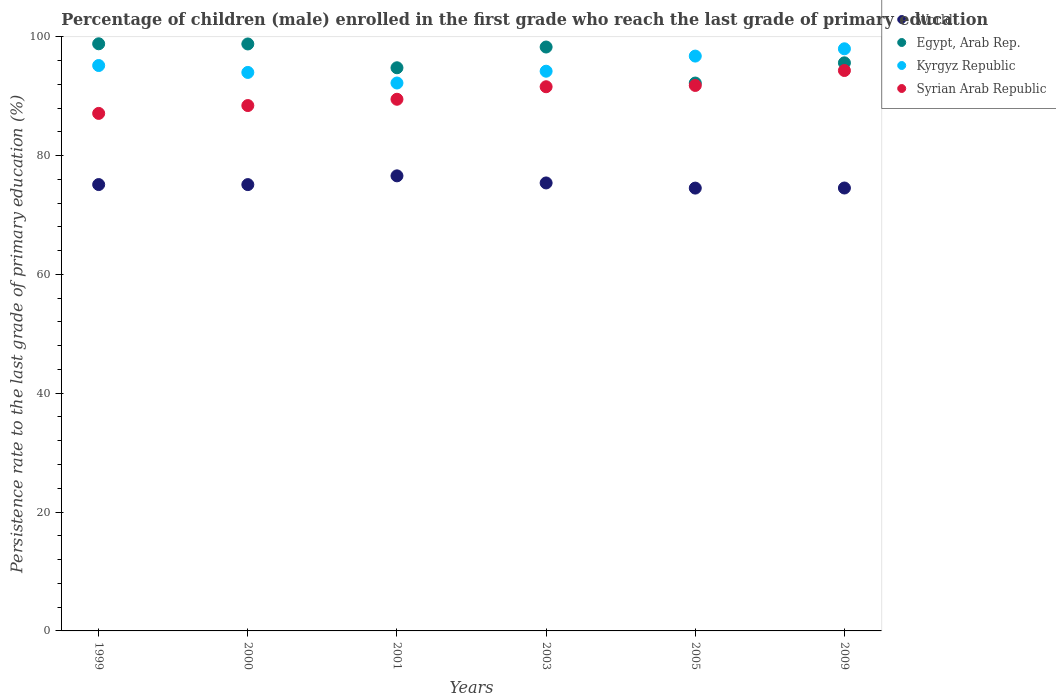How many different coloured dotlines are there?
Ensure brevity in your answer.  4. Is the number of dotlines equal to the number of legend labels?
Keep it short and to the point. Yes. What is the persistence rate of children in Kyrgyz Republic in 2000?
Offer a terse response. 93.99. Across all years, what is the maximum persistence rate of children in Egypt, Arab Rep.?
Offer a very short reply. 98.81. Across all years, what is the minimum persistence rate of children in World?
Offer a terse response. 74.52. In which year was the persistence rate of children in Syrian Arab Republic maximum?
Give a very brief answer. 2009. In which year was the persistence rate of children in Kyrgyz Republic minimum?
Keep it short and to the point. 2001. What is the total persistence rate of children in Syrian Arab Republic in the graph?
Offer a very short reply. 542.65. What is the difference between the persistence rate of children in Egypt, Arab Rep. in 1999 and that in 2009?
Your response must be concise. 3.2. What is the difference between the persistence rate of children in Egypt, Arab Rep. in 2003 and the persistence rate of children in Syrian Arab Republic in 1999?
Give a very brief answer. 11.17. What is the average persistence rate of children in Kyrgyz Republic per year?
Provide a succinct answer. 95.04. In the year 2001, what is the difference between the persistence rate of children in Egypt, Arab Rep. and persistence rate of children in World?
Ensure brevity in your answer.  18.19. What is the ratio of the persistence rate of children in Syrian Arab Republic in 2000 to that in 2003?
Keep it short and to the point. 0.97. Is the persistence rate of children in Egypt, Arab Rep. in 2000 less than that in 2001?
Provide a short and direct response. No. Is the difference between the persistence rate of children in Egypt, Arab Rep. in 2003 and 2009 greater than the difference between the persistence rate of children in World in 2003 and 2009?
Offer a terse response. Yes. What is the difference between the highest and the second highest persistence rate of children in World?
Make the answer very short. 1.19. What is the difference between the highest and the lowest persistence rate of children in Syrian Arab Republic?
Your response must be concise. 7.22. In how many years, is the persistence rate of children in Egypt, Arab Rep. greater than the average persistence rate of children in Egypt, Arab Rep. taken over all years?
Keep it short and to the point. 3. Is the sum of the persistence rate of children in Syrian Arab Republic in 2003 and 2009 greater than the maximum persistence rate of children in World across all years?
Your response must be concise. Yes. Is it the case that in every year, the sum of the persistence rate of children in Egypt, Arab Rep. and persistence rate of children in Kyrgyz Republic  is greater than the sum of persistence rate of children in Syrian Arab Republic and persistence rate of children in World?
Provide a short and direct response. Yes. Is the persistence rate of children in Kyrgyz Republic strictly less than the persistence rate of children in World over the years?
Keep it short and to the point. No. How many dotlines are there?
Make the answer very short. 4. How many years are there in the graph?
Offer a terse response. 6. Does the graph contain grids?
Make the answer very short. No. Where does the legend appear in the graph?
Provide a succinct answer. Top right. How many legend labels are there?
Your response must be concise. 4. How are the legend labels stacked?
Ensure brevity in your answer.  Vertical. What is the title of the graph?
Provide a short and direct response. Percentage of children (male) enrolled in the first grade who reach the last grade of primary education. What is the label or title of the Y-axis?
Offer a very short reply. Persistence rate to the last grade of primary education (%). What is the Persistence rate to the last grade of primary education (%) of World in 1999?
Offer a terse response. 75.12. What is the Persistence rate to the last grade of primary education (%) in Egypt, Arab Rep. in 1999?
Make the answer very short. 98.81. What is the Persistence rate to the last grade of primary education (%) in Kyrgyz Republic in 1999?
Provide a succinct answer. 95.15. What is the Persistence rate to the last grade of primary education (%) in Syrian Arab Republic in 1999?
Make the answer very short. 87.09. What is the Persistence rate to the last grade of primary education (%) in World in 2000?
Your answer should be very brief. 75.11. What is the Persistence rate to the last grade of primary education (%) of Egypt, Arab Rep. in 2000?
Make the answer very short. 98.78. What is the Persistence rate to the last grade of primary education (%) in Kyrgyz Republic in 2000?
Provide a short and direct response. 93.99. What is the Persistence rate to the last grade of primary education (%) in Syrian Arab Republic in 2000?
Provide a succinct answer. 88.41. What is the Persistence rate to the last grade of primary education (%) of World in 2001?
Ensure brevity in your answer.  76.58. What is the Persistence rate to the last grade of primary education (%) in Egypt, Arab Rep. in 2001?
Keep it short and to the point. 94.77. What is the Persistence rate to the last grade of primary education (%) of Kyrgyz Republic in 2001?
Your response must be concise. 92.2. What is the Persistence rate to the last grade of primary education (%) in Syrian Arab Republic in 2001?
Your answer should be compact. 89.47. What is the Persistence rate to the last grade of primary education (%) of World in 2003?
Offer a terse response. 75.39. What is the Persistence rate to the last grade of primary education (%) in Egypt, Arab Rep. in 2003?
Make the answer very short. 98.26. What is the Persistence rate to the last grade of primary education (%) in Kyrgyz Republic in 2003?
Offer a terse response. 94.19. What is the Persistence rate to the last grade of primary education (%) of Syrian Arab Republic in 2003?
Your answer should be very brief. 91.58. What is the Persistence rate to the last grade of primary education (%) of World in 2005?
Give a very brief answer. 74.52. What is the Persistence rate to the last grade of primary education (%) in Egypt, Arab Rep. in 2005?
Your answer should be very brief. 92.2. What is the Persistence rate to the last grade of primary education (%) of Kyrgyz Republic in 2005?
Give a very brief answer. 96.74. What is the Persistence rate to the last grade of primary education (%) in Syrian Arab Republic in 2005?
Give a very brief answer. 91.8. What is the Persistence rate to the last grade of primary education (%) in World in 2009?
Provide a short and direct response. 74.54. What is the Persistence rate to the last grade of primary education (%) of Egypt, Arab Rep. in 2009?
Offer a very short reply. 95.6. What is the Persistence rate to the last grade of primary education (%) of Kyrgyz Republic in 2009?
Offer a very short reply. 97.96. What is the Persistence rate to the last grade of primary education (%) of Syrian Arab Republic in 2009?
Give a very brief answer. 94.31. Across all years, what is the maximum Persistence rate to the last grade of primary education (%) in World?
Offer a very short reply. 76.58. Across all years, what is the maximum Persistence rate to the last grade of primary education (%) in Egypt, Arab Rep.?
Keep it short and to the point. 98.81. Across all years, what is the maximum Persistence rate to the last grade of primary education (%) in Kyrgyz Republic?
Your answer should be very brief. 97.96. Across all years, what is the maximum Persistence rate to the last grade of primary education (%) of Syrian Arab Republic?
Your response must be concise. 94.31. Across all years, what is the minimum Persistence rate to the last grade of primary education (%) of World?
Offer a very short reply. 74.52. Across all years, what is the minimum Persistence rate to the last grade of primary education (%) of Egypt, Arab Rep.?
Make the answer very short. 92.2. Across all years, what is the minimum Persistence rate to the last grade of primary education (%) in Kyrgyz Republic?
Provide a succinct answer. 92.2. Across all years, what is the minimum Persistence rate to the last grade of primary education (%) in Syrian Arab Republic?
Offer a terse response. 87.09. What is the total Persistence rate to the last grade of primary education (%) in World in the graph?
Your answer should be very brief. 451.25. What is the total Persistence rate to the last grade of primary education (%) in Egypt, Arab Rep. in the graph?
Offer a very short reply. 578.42. What is the total Persistence rate to the last grade of primary education (%) in Kyrgyz Republic in the graph?
Ensure brevity in your answer.  570.23. What is the total Persistence rate to the last grade of primary education (%) in Syrian Arab Republic in the graph?
Offer a terse response. 542.65. What is the difference between the Persistence rate to the last grade of primary education (%) of World in 1999 and that in 2000?
Offer a terse response. 0.01. What is the difference between the Persistence rate to the last grade of primary education (%) in Egypt, Arab Rep. in 1999 and that in 2000?
Keep it short and to the point. 0.03. What is the difference between the Persistence rate to the last grade of primary education (%) in Kyrgyz Republic in 1999 and that in 2000?
Provide a succinct answer. 1.16. What is the difference between the Persistence rate to the last grade of primary education (%) of Syrian Arab Republic in 1999 and that in 2000?
Your answer should be compact. -1.32. What is the difference between the Persistence rate to the last grade of primary education (%) of World in 1999 and that in 2001?
Your answer should be very brief. -1.47. What is the difference between the Persistence rate to the last grade of primary education (%) of Egypt, Arab Rep. in 1999 and that in 2001?
Offer a terse response. 4.04. What is the difference between the Persistence rate to the last grade of primary education (%) of Kyrgyz Republic in 1999 and that in 2001?
Offer a terse response. 2.94. What is the difference between the Persistence rate to the last grade of primary education (%) of Syrian Arab Republic in 1999 and that in 2001?
Your answer should be compact. -2.38. What is the difference between the Persistence rate to the last grade of primary education (%) of World in 1999 and that in 2003?
Make the answer very short. -0.27. What is the difference between the Persistence rate to the last grade of primary education (%) in Egypt, Arab Rep. in 1999 and that in 2003?
Give a very brief answer. 0.54. What is the difference between the Persistence rate to the last grade of primary education (%) in Syrian Arab Republic in 1999 and that in 2003?
Ensure brevity in your answer.  -4.49. What is the difference between the Persistence rate to the last grade of primary education (%) of World in 1999 and that in 2005?
Provide a succinct answer. 0.59. What is the difference between the Persistence rate to the last grade of primary education (%) in Egypt, Arab Rep. in 1999 and that in 2005?
Keep it short and to the point. 6.61. What is the difference between the Persistence rate to the last grade of primary education (%) of Kyrgyz Republic in 1999 and that in 2005?
Make the answer very short. -1.59. What is the difference between the Persistence rate to the last grade of primary education (%) in Syrian Arab Republic in 1999 and that in 2005?
Offer a terse response. -4.7. What is the difference between the Persistence rate to the last grade of primary education (%) in World in 1999 and that in 2009?
Provide a short and direct response. 0.58. What is the difference between the Persistence rate to the last grade of primary education (%) of Egypt, Arab Rep. in 1999 and that in 2009?
Ensure brevity in your answer.  3.2. What is the difference between the Persistence rate to the last grade of primary education (%) in Kyrgyz Republic in 1999 and that in 2009?
Ensure brevity in your answer.  -2.82. What is the difference between the Persistence rate to the last grade of primary education (%) in Syrian Arab Republic in 1999 and that in 2009?
Your answer should be compact. -7.22. What is the difference between the Persistence rate to the last grade of primary education (%) in World in 2000 and that in 2001?
Your answer should be very brief. -1.47. What is the difference between the Persistence rate to the last grade of primary education (%) of Egypt, Arab Rep. in 2000 and that in 2001?
Keep it short and to the point. 4.01. What is the difference between the Persistence rate to the last grade of primary education (%) of Kyrgyz Republic in 2000 and that in 2001?
Your answer should be very brief. 1.78. What is the difference between the Persistence rate to the last grade of primary education (%) in Syrian Arab Republic in 2000 and that in 2001?
Provide a short and direct response. -1.06. What is the difference between the Persistence rate to the last grade of primary education (%) in World in 2000 and that in 2003?
Your answer should be very brief. -0.28. What is the difference between the Persistence rate to the last grade of primary education (%) of Egypt, Arab Rep. in 2000 and that in 2003?
Make the answer very short. 0.52. What is the difference between the Persistence rate to the last grade of primary education (%) of Kyrgyz Republic in 2000 and that in 2003?
Your response must be concise. -0.21. What is the difference between the Persistence rate to the last grade of primary education (%) of Syrian Arab Republic in 2000 and that in 2003?
Offer a very short reply. -3.17. What is the difference between the Persistence rate to the last grade of primary education (%) in World in 2000 and that in 2005?
Offer a terse response. 0.59. What is the difference between the Persistence rate to the last grade of primary education (%) of Egypt, Arab Rep. in 2000 and that in 2005?
Give a very brief answer. 6.58. What is the difference between the Persistence rate to the last grade of primary education (%) of Kyrgyz Republic in 2000 and that in 2005?
Your answer should be very brief. -2.75. What is the difference between the Persistence rate to the last grade of primary education (%) in Syrian Arab Republic in 2000 and that in 2005?
Offer a terse response. -3.38. What is the difference between the Persistence rate to the last grade of primary education (%) of World in 2000 and that in 2009?
Make the answer very short. 0.57. What is the difference between the Persistence rate to the last grade of primary education (%) of Egypt, Arab Rep. in 2000 and that in 2009?
Your answer should be compact. 3.17. What is the difference between the Persistence rate to the last grade of primary education (%) of Kyrgyz Republic in 2000 and that in 2009?
Offer a terse response. -3.98. What is the difference between the Persistence rate to the last grade of primary education (%) of Syrian Arab Republic in 2000 and that in 2009?
Your answer should be compact. -5.9. What is the difference between the Persistence rate to the last grade of primary education (%) in World in 2001 and that in 2003?
Give a very brief answer. 1.19. What is the difference between the Persistence rate to the last grade of primary education (%) in Egypt, Arab Rep. in 2001 and that in 2003?
Your answer should be compact. -3.49. What is the difference between the Persistence rate to the last grade of primary education (%) in Kyrgyz Republic in 2001 and that in 2003?
Keep it short and to the point. -1.99. What is the difference between the Persistence rate to the last grade of primary education (%) in Syrian Arab Republic in 2001 and that in 2003?
Your response must be concise. -2.11. What is the difference between the Persistence rate to the last grade of primary education (%) of World in 2001 and that in 2005?
Give a very brief answer. 2.06. What is the difference between the Persistence rate to the last grade of primary education (%) in Egypt, Arab Rep. in 2001 and that in 2005?
Your response must be concise. 2.57. What is the difference between the Persistence rate to the last grade of primary education (%) in Kyrgyz Republic in 2001 and that in 2005?
Ensure brevity in your answer.  -4.53. What is the difference between the Persistence rate to the last grade of primary education (%) in Syrian Arab Republic in 2001 and that in 2005?
Make the answer very short. -2.33. What is the difference between the Persistence rate to the last grade of primary education (%) of World in 2001 and that in 2009?
Offer a terse response. 2.05. What is the difference between the Persistence rate to the last grade of primary education (%) in Egypt, Arab Rep. in 2001 and that in 2009?
Give a very brief answer. -0.83. What is the difference between the Persistence rate to the last grade of primary education (%) of Kyrgyz Republic in 2001 and that in 2009?
Provide a succinct answer. -5.76. What is the difference between the Persistence rate to the last grade of primary education (%) in Syrian Arab Republic in 2001 and that in 2009?
Make the answer very short. -4.84. What is the difference between the Persistence rate to the last grade of primary education (%) in World in 2003 and that in 2005?
Provide a succinct answer. 0.87. What is the difference between the Persistence rate to the last grade of primary education (%) in Egypt, Arab Rep. in 2003 and that in 2005?
Your answer should be very brief. 6.06. What is the difference between the Persistence rate to the last grade of primary education (%) of Kyrgyz Republic in 2003 and that in 2005?
Ensure brevity in your answer.  -2.55. What is the difference between the Persistence rate to the last grade of primary education (%) in Syrian Arab Republic in 2003 and that in 2005?
Offer a terse response. -0.22. What is the difference between the Persistence rate to the last grade of primary education (%) in World in 2003 and that in 2009?
Provide a succinct answer. 0.85. What is the difference between the Persistence rate to the last grade of primary education (%) of Egypt, Arab Rep. in 2003 and that in 2009?
Ensure brevity in your answer.  2.66. What is the difference between the Persistence rate to the last grade of primary education (%) of Kyrgyz Republic in 2003 and that in 2009?
Give a very brief answer. -3.77. What is the difference between the Persistence rate to the last grade of primary education (%) in Syrian Arab Republic in 2003 and that in 2009?
Offer a very short reply. -2.73. What is the difference between the Persistence rate to the last grade of primary education (%) of World in 2005 and that in 2009?
Offer a terse response. -0.01. What is the difference between the Persistence rate to the last grade of primary education (%) of Egypt, Arab Rep. in 2005 and that in 2009?
Provide a short and direct response. -3.4. What is the difference between the Persistence rate to the last grade of primary education (%) of Kyrgyz Republic in 2005 and that in 2009?
Give a very brief answer. -1.23. What is the difference between the Persistence rate to the last grade of primary education (%) of Syrian Arab Republic in 2005 and that in 2009?
Provide a short and direct response. -2.51. What is the difference between the Persistence rate to the last grade of primary education (%) in World in 1999 and the Persistence rate to the last grade of primary education (%) in Egypt, Arab Rep. in 2000?
Your answer should be very brief. -23.66. What is the difference between the Persistence rate to the last grade of primary education (%) of World in 1999 and the Persistence rate to the last grade of primary education (%) of Kyrgyz Republic in 2000?
Make the answer very short. -18.87. What is the difference between the Persistence rate to the last grade of primary education (%) of World in 1999 and the Persistence rate to the last grade of primary education (%) of Syrian Arab Republic in 2000?
Offer a very short reply. -13.3. What is the difference between the Persistence rate to the last grade of primary education (%) in Egypt, Arab Rep. in 1999 and the Persistence rate to the last grade of primary education (%) in Kyrgyz Republic in 2000?
Provide a succinct answer. 4.82. What is the difference between the Persistence rate to the last grade of primary education (%) in Egypt, Arab Rep. in 1999 and the Persistence rate to the last grade of primary education (%) in Syrian Arab Republic in 2000?
Provide a succinct answer. 10.39. What is the difference between the Persistence rate to the last grade of primary education (%) in Kyrgyz Republic in 1999 and the Persistence rate to the last grade of primary education (%) in Syrian Arab Republic in 2000?
Keep it short and to the point. 6.74. What is the difference between the Persistence rate to the last grade of primary education (%) of World in 1999 and the Persistence rate to the last grade of primary education (%) of Egypt, Arab Rep. in 2001?
Make the answer very short. -19.66. What is the difference between the Persistence rate to the last grade of primary education (%) of World in 1999 and the Persistence rate to the last grade of primary education (%) of Kyrgyz Republic in 2001?
Keep it short and to the point. -17.09. What is the difference between the Persistence rate to the last grade of primary education (%) of World in 1999 and the Persistence rate to the last grade of primary education (%) of Syrian Arab Republic in 2001?
Give a very brief answer. -14.35. What is the difference between the Persistence rate to the last grade of primary education (%) of Egypt, Arab Rep. in 1999 and the Persistence rate to the last grade of primary education (%) of Kyrgyz Republic in 2001?
Keep it short and to the point. 6.6. What is the difference between the Persistence rate to the last grade of primary education (%) of Egypt, Arab Rep. in 1999 and the Persistence rate to the last grade of primary education (%) of Syrian Arab Republic in 2001?
Give a very brief answer. 9.34. What is the difference between the Persistence rate to the last grade of primary education (%) in Kyrgyz Republic in 1999 and the Persistence rate to the last grade of primary education (%) in Syrian Arab Republic in 2001?
Your answer should be very brief. 5.68. What is the difference between the Persistence rate to the last grade of primary education (%) in World in 1999 and the Persistence rate to the last grade of primary education (%) in Egypt, Arab Rep. in 2003?
Offer a very short reply. -23.15. What is the difference between the Persistence rate to the last grade of primary education (%) of World in 1999 and the Persistence rate to the last grade of primary education (%) of Kyrgyz Republic in 2003?
Ensure brevity in your answer.  -19.08. What is the difference between the Persistence rate to the last grade of primary education (%) in World in 1999 and the Persistence rate to the last grade of primary education (%) in Syrian Arab Republic in 2003?
Give a very brief answer. -16.46. What is the difference between the Persistence rate to the last grade of primary education (%) of Egypt, Arab Rep. in 1999 and the Persistence rate to the last grade of primary education (%) of Kyrgyz Republic in 2003?
Make the answer very short. 4.62. What is the difference between the Persistence rate to the last grade of primary education (%) in Egypt, Arab Rep. in 1999 and the Persistence rate to the last grade of primary education (%) in Syrian Arab Republic in 2003?
Your answer should be very brief. 7.23. What is the difference between the Persistence rate to the last grade of primary education (%) of Kyrgyz Republic in 1999 and the Persistence rate to the last grade of primary education (%) of Syrian Arab Republic in 2003?
Provide a succinct answer. 3.57. What is the difference between the Persistence rate to the last grade of primary education (%) in World in 1999 and the Persistence rate to the last grade of primary education (%) in Egypt, Arab Rep. in 2005?
Ensure brevity in your answer.  -17.09. What is the difference between the Persistence rate to the last grade of primary education (%) in World in 1999 and the Persistence rate to the last grade of primary education (%) in Kyrgyz Republic in 2005?
Offer a terse response. -21.62. What is the difference between the Persistence rate to the last grade of primary education (%) in World in 1999 and the Persistence rate to the last grade of primary education (%) in Syrian Arab Republic in 2005?
Your answer should be compact. -16.68. What is the difference between the Persistence rate to the last grade of primary education (%) of Egypt, Arab Rep. in 1999 and the Persistence rate to the last grade of primary education (%) of Kyrgyz Republic in 2005?
Your answer should be very brief. 2.07. What is the difference between the Persistence rate to the last grade of primary education (%) in Egypt, Arab Rep. in 1999 and the Persistence rate to the last grade of primary education (%) in Syrian Arab Republic in 2005?
Your answer should be compact. 7.01. What is the difference between the Persistence rate to the last grade of primary education (%) of Kyrgyz Republic in 1999 and the Persistence rate to the last grade of primary education (%) of Syrian Arab Republic in 2005?
Offer a terse response. 3.35. What is the difference between the Persistence rate to the last grade of primary education (%) in World in 1999 and the Persistence rate to the last grade of primary education (%) in Egypt, Arab Rep. in 2009?
Provide a succinct answer. -20.49. What is the difference between the Persistence rate to the last grade of primary education (%) in World in 1999 and the Persistence rate to the last grade of primary education (%) in Kyrgyz Republic in 2009?
Provide a short and direct response. -22.85. What is the difference between the Persistence rate to the last grade of primary education (%) of World in 1999 and the Persistence rate to the last grade of primary education (%) of Syrian Arab Republic in 2009?
Give a very brief answer. -19.19. What is the difference between the Persistence rate to the last grade of primary education (%) in Egypt, Arab Rep. in 1999 and the Persistence rate to the last grade of primary education (%) in Kyrgyz Republic in 2009?
Give a very brief answer. 0.84. What is the difference between the Persistence rate to the last grade of primary education (%) of Egypt, Arab Rep. in 1999 and the Persistence rate to the last grade of primary education (%) of Syrian Arab Republic in 2009?
Ensure brevity in your answer.  4.5. What is the difference between the Persistence rate to the last grade of primary education (%) in Kyrgyz Republic in 1999 and the Persistence rate to the last grade of primary education (%) in Syrian Arab Republic in 2009?
Offer a very short reply. 0.84. What is the difference between the Persistence rate to the last grade of primary education (%) of World in 2000 and the Persistence rate to the last grade of primary education (%) of Egypt, Arab Rep. in 2001?
Keep it short and to the point. -19.66. What is the difference between the Persistence rate to the last grade of primary education (%) of World in 2000 and the Persistence rate to the last grade of primary education (%) of Kyrgyz Republic in 2001?
Make the answer very short. -17.1. What is the difference between the Persistence rate to the last grade of primary education (%) of World in 2000 and the Persistence rate to the last grade of primary education (%) of Syrian Arab Republic in 2001?
Ensure brevity in your answer.  -14.36. What is the difference between the Persistence rate to the last grade of primary education (%) of Egypt, Arab Rep. in 2000 and the Persistence rate to the last grade of primary education (%) of Kyrgyz Republic in 2001?
Keep it short and to the point. 6.57. What is the difference between the Persistence rate to the last grade of primary education (%) in Egypt, Arab Rep. in 2000 and the Persistence rate to the last grade of primary education (%) in Syrian Arab Republic in 2001?
Make the answer very short. 9.31. What is the difference between the Persistence rate to the last grade of primary education (%) in Kyrgyz Republic in 2000 and the Persistence rate to the last grade of primary education (%) in Syrian Arab Republic in 2001?
Your response must be concise. 4.51. What is the difference between the Persistence rate to the last grade of primary education (%) in World in 2000 and the Persistence rate to the last grade of primary education (%) in Egypt, Arab Rep. in 2003?
Give a very brief answer. -23.15. What is the difference between the Persistence rate to the last grade of primary education (%) in World in 2000 and the Persistence rate to the last grade of primary education (%) in Kyrgyz Republic in 2003?
Provide a succinct answer. -19.08. What is the difference between the Persistence rate to the last grade of primary education (%) of World in 2000 and the Persistence rate to the last grade of primary education (%) of Syrian Arab Republic in 2003?
Ensure brevity in your answer.  -16.47. What is the difference between the Persistence rate to the last grade of primary education (%) of Egypt, Arab Rep. in 2000 and the Persistence rate to the last grade of primary education (%) of Kyrgyz Republic in 2003?
Your answer should be very brief. 4.59. What is the difference between the Persistence rate to the last grade of primary education (%) of Egypt, Arab Rep. in 2000 and the Persistence rate to the last grade of primary education (%) of Syrian Arab Republic in 2003?
Keep it short and to the point. 7.2. What is the difference between the Persistence rate to the last grade of primary education (%) in Kyrgyz Republic in 2000 and the Persistence rate to the last grade of primary education (%) in Syrian Arab Republic in 2003?
Give a very brief answer. 2.41. What is the difference between the Persistence rate to the last grade of primary education (%) of World in 2000 and the Persistence rate to the last grade of primary education (%) of Egypt, Arab Rep. in 2005?
Provide a succinct answer. -17.09. What is the difference between the Persistence rate to the last grade of primary education (%) in World in 2000 and the Persistence rate to the last grade of primary education (%) in Kyrgyz Republic in 2005?
Ensure brevity in your answer.  -21.63. What is the difference between the Persistence rate to the last grade of primary education (%) in World in 2000 and the Persistence rate to the last grade of primary education (%) in Syrian Arab Republic in 2005?
Your answer should be compact. -16.69. What is the difference between the Persistence rate to the last grade of primary education (%) of Egypt, Arab Rep. in 2000 and the Persistence rate to the last grade of primary education (%) of Kyrgyz Republic in 2005?
Ensure brevity in your answer.  2.04. What is the difference between the Persistence rate to the last grade of primary education (%) in Egypt, Arab Rep. in 2000 and the Persistence rate to the last grade of primary education (%) in Syrian Arab Republic in 2005?
Ensure brevity in your answer.  6.98. What is the difference between the Persistence rate to the last grade of primary education (%) of Kyrgyz Republic in 2000 and the Persistence rate to the last grade of primary education (%) of Syrian Arab Republic in 2005?
Offer a terse response. 2.19. What is the difference between the Persistence rate to the last grade of primary education (%) in World in 2000 and the Persistence rate to the last grade of primary education (%) in Egypt, Arab Rep. in 2009?
Provide a short and direct response. -20.49. What is the difference between the Persistence rate to the last grade of primary education (%) in World in 2000 and the Persistence rate to the last grade of primary education (%) in Kyrgyz Republic in 2009?
Your answer should be very brief. -22.86. What is the difference between the Persistence rate to the last grade of primary education (%) of World in 2000 and the Persistence rate to the last grade of primary education (%) of Syrian Arab Republic in 2009?
Ensure brevity in your answer.  -19.2. What is the difference between the Persistence rate to the last grade of primary education (%) of Egypt, Arab Rep. in 2000 and the Persistence rate to the last grade of primary education (%) of Kyrgyz Republic in 2009?
Offer a very short reply. 0.81. What is the difference between the Persistence rate to the last grade of primary education (%) in Egypt, Arab Rep. in 2000 and the Persistence rate to the last grade of primary education (%) in Syrian Arab Republic in 2009?
Offer a very short reply. 4.47. What is the difference between the Persistence rate to the last grade of primary education (%) in Kyrgyz Republic in 2000 and the Persistence rate to the last grade of primary education (%) in Syrian Arab Republic in 2009?
Provide a succinct answer. -0.32. What is the difference between the Persistence rate to the last grade of primary education (%) of World in 2001 and the Persistence rate to the last grade of primary education (%) of Egypt, Arab Rep. in 2003?
Ensure brevity in your answer.  -21.68. What is the difference between the Persistence rate to the last grade of primary education (%) in World in 2001 and the Persistence rate to the last grade of primary education (%) in Kyrgyz Republic in 2003?
Your response must be concise. -17.61. What is the difference between the Persistence rate to the last grade of primary education (%) of World in 2001 and the Persistence rate to the last grade of primary education (%) of Syrian Arab Republic in 2003?
Ensure brevity in your answer.  -15. What is the difference between the Persistence rate to the last grade of primary education (%) of Egypt, Arab Rep. in 2001 and the Persistence rate to the last grade of primary education (%) of Kyrgyz Republic in 2003?
Your response must be concise. 0.58. What is the difference between the Persistence rate to the last grade of primary education (%) of Egypt, Arab Rep. in 2001 and the Persistence rate to the last grade of primary education (%) of Syrian Arab Republic in 2003?
Ensure brevity in your answer.  3.19. What is the difference between the Persistence rate to the last grade of primary education (%) in Kyrgyz Republic in 2001 and the Persistence rate to the last grade of primary education (%) in Syrian Arab Republic in 2003?
Make the answer very short. 0.63. What is the difference between the Persistence rate to the last grade of primary education (%) of World in 2001 and the Persistence rate to the last grade of primary education (%) of Egypt, Arab Rep. in 2005?
Give a very brief answer. -15.62. What is the difference between the Persistence rate to the last grade of primary education (%) in World in 2001 and the Persistence rate to the last grade of primary education (%) in Kyrgyz Republic in 2005?
Provide a succinct answer. -20.15. What is the difference between the Persistence rate to the last grade of primary education (%) in World in 2001 and the Persistence rate to the last grade of primary education (%) in Syrian Arab Republic in 2005?
Provide a succinct answer. -15.21. What is the difference between the Persistence rate to the last grade of primary education (%) in Egypt, Arab Rep. in 2001 and the Persistence rate to the last grade of primary education (%) in Kyrgyz Republic in 2005?
Provide a succinct answer. -1.97. What is the difference between the Persistence rate to the last grade of primary education (%) of Egypt, Arab Rep. in 2001 and the Persistence rate to the last grade of primary education (%) of Syrian Arab Republic in 2005?
Give a very brief answer. 2.98. What is the difference between the Persistence rate to the last grade of primary education (%) in Kyrgyz Republic in 2001 and the Persistence rate to the last grade of primary education (%) in Syrian Arab Republic in 2005?
Your answer should be very brief. 0.41. What is the difference between the Persistence rate to the last grade of primary education (%) in World in 2001 and the Persistence rate to the last grade of primary education (%) in Egypt, Arab Rep. in 2009?
Your answer should be compact. -19.02. What is the difference between the Persistence rate to the last grade of primary education (%) in World in 2001 and the Persistence rate to the last grade of primary education (%) in Kyrgyz Republic in 2009?
Keep it short and to the point. -21.38. What is the difference between the Persistence rate to the last grade of primary education (%) in World in 2001 and the Persistence rate to the last grade of primary education (%) in Syrian Arab Republic in 2009?
Your answer should be compact. -17.73. What is the difference between the Persistence rate to the last grade of primary education (%) in Egypt, Arab Rep. in 2001 and the Persistence rate to the last grade of primary education (%) in Kyrgyz Republic in 2009?
Provide a succinct answer. -3.19. What is the difference between the Persistence rate to the last grade of primary education (%) of Egypt, Arab Rep. in 2001 and the Persistence rate to the last grade of primary education (%) of Syrian Arab Republic in 2009?
Offer a very short reply. 0.46. What is the difference between the Persistence rate to the last grade of primary education (%) in Kyrgyz Republic in 2001 and the Persistence rate to the last grade of primary education (%) in Syrian Arab Republic in 2009?
Ensure brevity in your answer.  -2.1. What is the difference between the Persistence rate to the last grade of primary education (%) of World in 2003 and the Persistence rate to the last grade of primary education (%) of Egypt, Arab Rep. in 2005?
Keep it short and to the point. -16.81. What is the difference between the Persistence rate to the last grade of primary education (%) of World in 2003 and the Persistence rate to the last grade of primary education (%) of Kyrgyz Republic in 2005?
Give a very brief answer. -21.35. What is the difference between the Persistence rate to the last grade of primary education (%) in World in 2003 and the Persistence rate to the last grade of primary education (%) in Syrian Arab Republic in 2005?
Give a very brief answer. -16.41. What is the difference between the Persistence rate to the last grade of primary education (%) of Egypt, Arab Rep. in 2003 and the Persistence rate to the last grade of primary education (%) of Kyrgyz Republic in 2005?
Your answer should be compact. 1.52. What is the difference between the Persistence rate to the last grade of primary education (%) in Egypt, Arab Rep. in 2003 and the Persistence rate to the last grade of primary education (%) in Syrian Arab Republic in 2005?
Ensure brevity in your answer.  6.47. What is the difference between the Persistence rate to the last grade of primary education (%) of Kyrgyz Republic in 2003 and the Persistence rate to the last grade of primary education (%) of Syrian Arab Republic in 2005?
Give a very brief answer. 2.4. What is the difference between the Persistence rate to the last grade of primary education (%) of World in 2003 and the Persistence rate to the last grade of primary education (%) of Egypt, Arab Rep. in 2009?
Provide a short and direct response. -20.21. What is the difference between the Persistence rate to the last grade of primary education (%) of World in 2003 and the Persistence rate to the last grade of primary education (%) of Kyrgyz Republic in 2009?
Your answer should be very brief. -22.58. What is the difference between the Persistence rate to the last grade of primary education (%) in World in 2003 and the Persistence rate to the last grade of primary education (%) in Syrian Arab Republic in 2009?
Provide a succinct answer. -18.92. What is the difference between the Persistence rate to the last grade of primary education (%) in Egypt, Arab Rep. in 2003 and the Persistence rate to the last grade of primary education (%) in Kyrgyz Republic in 2009?
Provide a succinct answer. 0.3. What is the difference between the Persistence rate to the last grade of primary education (%) of Egypt, Arab Rep. in 2003 and the Persistence rate to the last grade of primary education (%) of Syrian Arab Republic in 2009?
Offer a very short reply. 3.95. What is the difference between the Persistence rate to the last grade of primary education (%) of Kyrgyz Republic in 2003 and the Persistence rate to the last grade of primary education (%) of Syrian Arab Republic in 2009?
Provide a succinct answer. -0.12. What is the difference between the Persistence rate to the last grade of primary education (%) of World in 2005 and the Persistence rate to the last grade of primary education (%) of Egypt, Arab Rep. in 2009?
Provide a succinct answer. -21.08. What is the difference between the Persistence rate to the last grade of primary education (%) of World in 2005 and the Persistence rate to the last grade of primary education (%) of Kyrgyz Republic in 2009?
Make the answer very short. -23.44. What is the difference between the Persistence rate to the last grade of primary education (%) of World in 2005 and the Persistence rate to the last grade of primary education (%) of Syrian Arab Republic in 2009?
Provide a short and direct response. -19.79. What is the difference between the Persistence rate to the last grade of primary education (%) in Egypt, Arab Rep. in 2005 and the Persistence rate to the last grade of primary education (%) in Kyrgyz Republic in 2009?
Provide a succinct answer. -5.76. What is the difference between the Persistence rate to the last grade of primary education (%) in Egypt, Arab Rep. in 2005 and the Persistence rate to the last grade of primary education (%) in Syrian Arab Republic in 2009?
Provide a short and direct response. -2.11. What is the difference between the Persistence rate to the last grade of primary education (%) in Kyrgyz Republic in 2005 and the Persistence rate to the last grade of primary education (%) in Syrian Arab Republic in 2009?
Your answer should be compact. 2.43. What is the average Persistence rate to the last grade of primary education (%) of World per year?
Your answer should be very brief. 75.21. What is the average Persistence rate to the last grade of primary education (%) in Egypt, Arab Rep. per year?
Make the answer very short. 96.4. What is the average Persistence rate to the last grade of primary education (%) of Kyrgyz Republic per year?
Your response must be concise. 95.04. What is the average Persistence rate to the last grade of primary education (%) in Syrian Arab Republic per year?
Provide a succinct answer. 90.44. In the year 1999, what is the difference between the Persistence rate to the last grade of primary education (%) in World and Persistence rate to the last grade of primary education (%) in Egypt, Arab Rep.?
Provide a succinct answer. -23.69. In the year 1999, what is the difference between the Persistence rate to the last grade of primary education (%) in World and Persistence rate to the last grade of primary education (%) in Kyrgyz Republic?
Ensure brevity in your answer.  -20.03. In the year 1999, what is the difference between the Persistence rate to the last grade of primary education (%) in World and Persistence rate to the last grade of primary education (%) in Syrian Arab Republic?
Ensure brevity in your answer.  -11.97. In the year 1999, what is the difference between the Persistence rate to the last grade of primary education (%) of Egypt, Arab Rep. and Persistence rate to the last grade of primary education (%) of Kyrgyz Republic?
Your answer should be compact. 3.66. In the year 1999, what is the difference between the Persistence rate to the last grade of primary education (%) in Egypt, Arab Rep. and Persistence rate to the last grade of primary education (%) in Syrian Arab Republic?
Make the answer very short. 11.72. In the year 1999, what is the difference between the Persistence rate to the last grade of primary education (%) of Kyrgyz Republic and Persistence rate to the last grade of primary education (%) of Syrian Arab Republic?
Keep it short and to the point. 8.06. In the year 2000, what is the difference between the Persistence rate to the last grade of primary education (%) in World and Persistence rate to the last grade of primary education (%) in Egypt, Arab Rep.?
Provide a short and direct response. -23.67. In the year 2000, what is the difference between the Persistence rate to the last grade of primary education (%) of World and Persistence rate to the last grade of primary education (%) of Kyrgyz Republic?
Provide a succinct answer. -18.88. In the year 2000, what is the difference between the Persistence rate to the last grade of primary education (%) of World and Persistence rate to the last grade of primary education (%) of Syrian Arab Republic?
Offer a terse response. -13.3. In the year 2000, what is the difference between the Persistence rate to the last grade of primary education (%) of Egypt, Arab Rep. and Persistence rate to the last grade of primary education (%) of Kyrgyz Republic?
Your answer should be very brief. 4.79. In the year 2000, what is the difference between the Persistence rate to the last grade of primary education (%) of Egypt, Arab Rep. and Persistence rate to the last grade of primary education (%) of Syrian Arab Republic?
Keep it short and to the point. 10.36. In the year 2000, what is the difference between the Persistence rate to the last grade of primary education (%) of Kyrgyz Republic and Persistence rate to the last grade of primary education (%) of Syrian Arab Republic?
Offer a very short reply. 5.57. In the year 2001, what is the difference between the Persistence rate to the last grade of primary education (%) in World and Persistence rate to the last grade of primary education (%) in Egypt, Arab Rep.?
Offer a terse response. -18.19. In the year 2001, what is the difference between the Persistence rate to the last grade of primary education (%) in World and Persistence rate to the last grade of primary education (%) in Kyrgyz Republic?
Your answer should be compact. -15.62. In the year 2001, what is the difference between the Persistence rate to the last grade of primary education (%) of World and Persistence rate to the last grade of primary education (%) of Syrian Arab Republic?
Give a very brief answer. -12.89. In the year 2001, what is the difference between the Persistence rate to the last grade of primary education (%) in Egypt, Arab Rep. and Persistence rate to the last grade of primary education (%) in Kyrgyz Republic?
Your answer should be very brief. 2.57. In the year 2001, what is the difference between the Persistence rate to the last grade of primary education (%) in Egypt, Arab Rep. and Persistence rate to the last grade of primary education (%) in Syrian Arab Republic?
Your answer should be compact. 5.3. In the year 2001, what is the difference between the Persistence rate to the last grade of primary education (%) of Kyrgyz Republic and Persistence rate to the last grade of primary education (%) of Syrian Arab Republic?
Your answer should be compact. 2.73. In the year 2003, what is the difference between the Persistence rate to the last grade of primary education (%) in World and Persistence rate to the last grade of primary education (%) in Egypt, Arab Rep.?
Give a very brief answer. -22.87. In the year 2003, what is the difference between the Persistence rate to the last grade of primary education (%) in World and Persistence rate to the last grade of primary education (%) in Kyrgyz Republic?
Ensure brevity in your answer.  -18.8. In the year 2003, what is the difference between the Persistence rate to the last grade of primary education (%) of World and Persistence rate to the last grade of primary education (%) of Syrian Arab Republic?
Offer a very short reply. -16.19. In the year 2003, what is the difference between the Persistence rate to the last grade of primary education (%) in Egypt, Arab Rep. and Persistence rate to the last grade of primary education (%) in Kyrgyz Republic?
Make the answer very short. 4.07. In the year 2003, what is the difference between the Persistence rate to the last grade of primary education (%) in Egypt, Arab Rep. and Persistence rate to the last grade of primary education (%) in Syrian Arab Republic?
Your response must be concise. 6.68. In the year 2003, what is the difference between the Persistence rate to the last grade of primary education (%) of Kyrgyz Republic and Persistence rate to the last grade of primary education (%) of Syrian Arab Republic?
Give a very brief answer. 2.61. In the year 2005, what is the difference between the Persistence rate to the last grade of primary education (%) of World and Persistence rate to the last grade of primary education (%) of Egypt, Arab Rep.?
Your answer should be compact. -17.68. In the year 2005, what is the difference between the Persistence rate to the last grade of primary education (%) in World and Persistence rate to the last grade of primary education (%) in Kyrgyz Republic?
Offer a terse response. -22.22. In the year 2005, what is the difference between the Persistence rate to the last grade of primary education (%) in World and Persistence rate to the last grade of primary education (%) in Syrian Arab Republic?
Your answer should be compact. -17.27. In the year 2005, what is the difference between the Persistence rate to the last grade of primary education (%) in Egypt, Arab Rep. and Persistence rate to the last grade of primary education (%) in Kyrgyz Republic?
Keep it short and to the point. -4.54. In the year 2005, what is the difference between the Persistence rate to the last grade of primary education (%) of Egypt, Arab Rep. and Persistence rate to the last grade of primary education (%) of Syrian Arab Republic?
Provide a short and direct response. 0.41. In the year 2005, what is the difference between the Persistence rate to the last grade of primary education (%) in Kyrgyz Republic and Persistence rate to the last grade of primary education (%) in Syrian Arab Republic?
Offer a terse response. 4.94. In the year 2009, what is the difference between the Persistence rate to the last grade of primary education (%) in World and Persistence rate to the last grade of primary education (%) in Egypt, Arab Rep.?
Your response must be concise. -21.07. In the year 2009, what is the difference between the Persistence rate to the last grade of primary education (%) of World and Persistence rate to the last grade of primary education (%) of Kyrgyz Republic?
Give a very brief answer. -23.43. In the year 2009, what is the difference between the Persistence rate to the last grade of primary education (%) of World and Persistence rate to the last grade of primary education (%) of Syrian Arab Republic?
Ensure brevity in your answer.  -19.77. In the year 2009, what is the difference between the Persistence rate to the last grade of primary education (%) in Egypt, Arab Rep. and Persistence rate to the last grade of primary education (%) in Kyrgyz Republic?
Provide a short and direct response. -2.36. In the year 2009, what is the difference between the Persistence rate to the last grade of primary education (%) of Egypt, Arab Rep. and Persistence rate to the last grade of primary education (%) of Syrian Arab Republic?
Provide a short and direct response. 1.29. In the year 2009, what is the difference between the Persistence rate to the last grade of primary education (%) in Kyrgyz Republic and Persistence rate to the last grade of primary education (%) in Syrian Arab Republic?
Keep it short and to the point. 3.66. What is the ratio of the Persistence rate to the last grade of primary education (%) in World in 1999 to that in 2000?
Provide a succinct answer. 1. What is the ratio of the Persistence rate to the last grade of primary education (%) of Egypt, Arab Rep. in 1999 to that in 2000?
Offer a terse response. 1. What is the ratio of the Persistence rate to the last grade of primary education (%) of Kyrgyz Republic in 1999 to that in 2000?
Offer a very short reply. 1.01. What is the ratio of the Persistence rate to the last grade of primary education (%) of Syrian Arab Republic in 1999 to that in 2000?
Make the answer very short. 0.99. What is the ratio of the Persistence rate to the last grade of primary education (%) of World in 1999 to that in 2001?
Keep it short and to the point. 0.98. What is the ratio of the Persistence rate to the last grade of primary education (%) in Egypt, Arab Rep. in 1999 to that in 2001?
Ensure brevity in your answer.  1.04. What is the ratio of the Persistence rate to the last grade of primary education (%) of Kyrgyz Republic in 1999 to that in 2001?
Provide a succinct answer. 1.03. What is the ratio of the Persistence rate to the last grade of primary education (%) in Syrian Arab Republic in 1999 to that in 2001?
Give a very brief answer. 0.97. What is the ratio of the Persistence rate to the last grade of primary education (%) in Egypt, Arab Rep. in 1999 to that in 2003?
Offer a very short reply. 1.01. What is the ratio of the Persistence rate to the last grade of primary education (%) of Kyrgyz Republic in 1999 to that in 2003?
Keep it short and to the point. 1.01. What is the ratio of the Persistence rate to the last grade of primary education (%) in Syrian Arab Republic in 1999 to that in 2003?
Your answer should be compact. 0.95. What is the ratio of the Persistence rate to the last grade of primary education (%) of World in 1999 to that in 2005?
Your response must be concise. 1.01. What is the ratio of the Persistence rate to the last grade of primary education (%) of Egypt, Arab Rep. in 1999 to that in 2005?
Your answer should be compact. 1.07. What is the ratio of the Persistence rate to the last grade of primary education (%) of Kyrgyz Republic in 1999 to that in 2005?
Your answer should be very brief. 0.98. What is the ratio of the Persistence rate to the last grade of primary education (%) of Syrian Arab Republic in 1999 to that in 2005?
Make the answer very short. 0.95. What is the ratio of the Persistence rate to the last grade of primary education (%) of Egypt, Arab Rep. in 1999 to that in 2009?
Offer a terse response. 1.03. What is the ratio of the Persistence rate to the last grade of primary education (%) in Kyrgyz Republic in 1999 to that in 2009?
Give a very brief answer. 0.97. What is the ratio of the Persistence rate to the last grade of primary education (%) in Syrian Arab Republic in 1999 to that in 2009?
Offer a terse response. 0.92. What is the ratio of the Persistence rate to the last grade of primary education (%) of World in 2000 to that in 2001?
Offer a very short reply. 0.98. What is the ratio of the Persistence rate to the last grade of primary education (%) in Egypt, Arab Rep. in 2000 to that in 2001?
Provide a succinct answer. 1.04. What is the ratio of the Persistence rate to the last grade of primary education (%) of Kyrgyz Republic in 2000 to that in 2001?
Your response must be concise. 1.02. What is the ratio of the Persistence rate to the last grade of primary education (%) of World in 2000 to that in 2003?
Provide a succinct answer. 1. What is the ratio of the Persistence rate to the last grade of primary education (%) in Egypt, Arab Rep. in 2000 to that in 2003?
Provide a succinct answer. 1.01. What is the ratio of the Persistence rate to the last grade of primary education (%) in Kyrgyz Republic in 2000 to that in 2003?
Offer a terse response. 1. What is the ratio of the Persistence rate to the last grade of primary education (%) in Syrian Arab Republic in 2000 to that in 2003?
Your answer should be very brief. 0.97. What is the ratio of the Persistence rate to the last grade of primary education (%) in World in 2000 to that in 2005?
Make the answer very short. 1.01. What is the ratio of the Persistence rate to the last grade of primary education (%) in Egypt, Arab Rep. in 2000 to that in 2005?
Provide a succinct answer. 1.07. What is the ratio of the Persistence rate to the last grade of primary education (%) of Kyrgyz Republic in 2000 to that in 2005?
Your answer should be very brief. 0.97. What is the ratio of the Persistence rate to the last grade of primary education (%) in Syrian Arab Republic in 2000 to that in 2005?
Ensure brevity in your answer.  0.96. What is the ratio of the Persistence rate to the last grade of primary education (%) of World in 2000 to that in 2009?
Offer a very short reply. 1.01. What is the ratio of the Persistence rate to the last grade of primary education (%) in Egypt, Arab Rep. in 2000 to that in 2009?
Make the answer very short. 1.03. What is the ratio of the Persistence rate to the last grade of primary education (%) in Kyrgyz Republic in 2000 to that in 2009?
Your response must be concise. 0.96. What is the ratio of the Persistence rate to the last grade of primary education (%) in World in 2001 to that in 2003?
Offer a terse response. 1.02. What is the ratio of the Persistence rate to the last grade of primary education (%) of Egypt, Arab Rep. in 2001 to that in 2003?
Give a very brief answer. 0.96. What is the ratio of the Persistence rate to the last grade of primary education (%) of Kyrgyz Republic in 2001 to that in 2003?
Provide a short and direct response. 0.98. What is the ratio of the Persistence rate to the last grade of primary education (%) of Syrian Arab Republic in 2001 to that in 2003?
Ensure brevity in your answer.  0.98. What is the ratio of the Persistence rate to the last grade of primary education (%) of World in 2001 to that in 2005?
Offer a terse response. 1.03. What is the ratio of the Persistence rate to the last grade of primary education (%) in Egypt, Arab Rep. in 2001 to that in 2005?
Keep it short and to the point. 1.03. What is the ratio of the Persistence rate to the last grade of primary education (%) in Kyrgyz Republic in 2001 to that in 2005?
Make the answer very short. 0.95. What is the ratio of the Persistence rate to the last grade of primary education (%) in Syrian Arab Republic in 2001 to that in 2005?
Give a very brief answer. 0.97. What is the ratio of the Persistence rate to the last grade of primary education (%) in World in 2001 to that in 2009?
Keep it short and to the point. 1.03. What is the ratio of the Persistence rate to the last grade of primary education (%) of Kyrgyz Republic in 2001 to that in 2009?
Make the answer very short. 0.94. What is the ratio of the Persistence rate to the last grade of primary education (%) of Syrian Arab Republic in 2001 to that in 2009?
Your answer should be very brief. 0.95. What is the ratio of the Persistence rate to the last grade of primary education (%) in World in 2003 to that in 2005?
Offer a very short reply. 1.01. What is the ratio of the Persistence rate to the last grade of primary education (%) of Egypt, Arab Rep. in 2003 to that in 2005?
Offer a terse response. 1.07. What is the ratio of the Persistence rate to the last grade of primary education (%) in Kyrgyz Republic in 2003 to that in 2005?
Give a very brief answer. 0.97. What is the ratio of the Persistence rate to the last grade of primary education (%) of World in 2003 to that in 2009?
Provide a short and direct response. 1.01. What is the ratio of the Persistence rate to the last grade of primary education (%) of Egypt, Arab Rep. in 2003 to that in 2009?
Provide a short and direct response. 1.03. What is the ratio of the Persistence rate to the last grade of primary education (%) in Kyrgyz Republic in 2003 to that in 2009?
Keep it short and to the point. 0.96. What is the ratio of the Persistence rate to the last grade of primary education (%) of Syrian Arab Republic in 2003 to that in 2009?
Ensure brevity in your answer.  0.97. What is the ratio of the Persistence rate to the last grade of primary education (%) of Egypt, Arab Rep. in 2005 to that in 2009?
Provide a short and direct response. 0.96. What is the ratio of the Persistence rate to the last grade of primary education (%) of Kyrgyz Republic in 2005 to that in 2009?
Offer a very short reply. 0.99. What is the ratio of the Persistence rate to the last grade of primary education (%) of Syrian Arab Republic in 2005 to that in 2009?
Provide a succinct answer. 0.97. What is the difference between the highest and the second highest Persistence rate to the last grade of primary education (%) of World?
Give a very brief answer. 1.19. What is the difference between the highest and the second highest Persistence rate to the last grade of primary education (%) of Egypt, Arab Rep.?
Give a very brief answer. 0.03. What is the difference between the highest and the second highest Persistence rate to the last grade of primary education (%) in Kyrgyz Republic?
Your response must be concise. 1.23. What is the difference between the highest and the second highest Persistence rate to the last grade of primary education (%) in Syrian Arab Republic?
Give a very brief answer. 2.51. What is the difference between the highest and the lowest Persistence rate to the last grade of primary education (%) of World?
Your response must be concise. 2.06. What is the difference between the highest and the lowest Persistence rate to the last grade of primary education (%) in Egypt, Arab Rep.?
Ensure brevity in your answer.  6.61. What is the difference between the highest and the lowest Persistence rate to the last grade of primary education (%) of Kyrgyz Republic?
Give a very brief answer. 5.76. What is the difference between the highest and the lowest Persistence rate to the last grade of primary education (%) in Syrian Arab Republic?
Give a very brief answer. 7.22. 